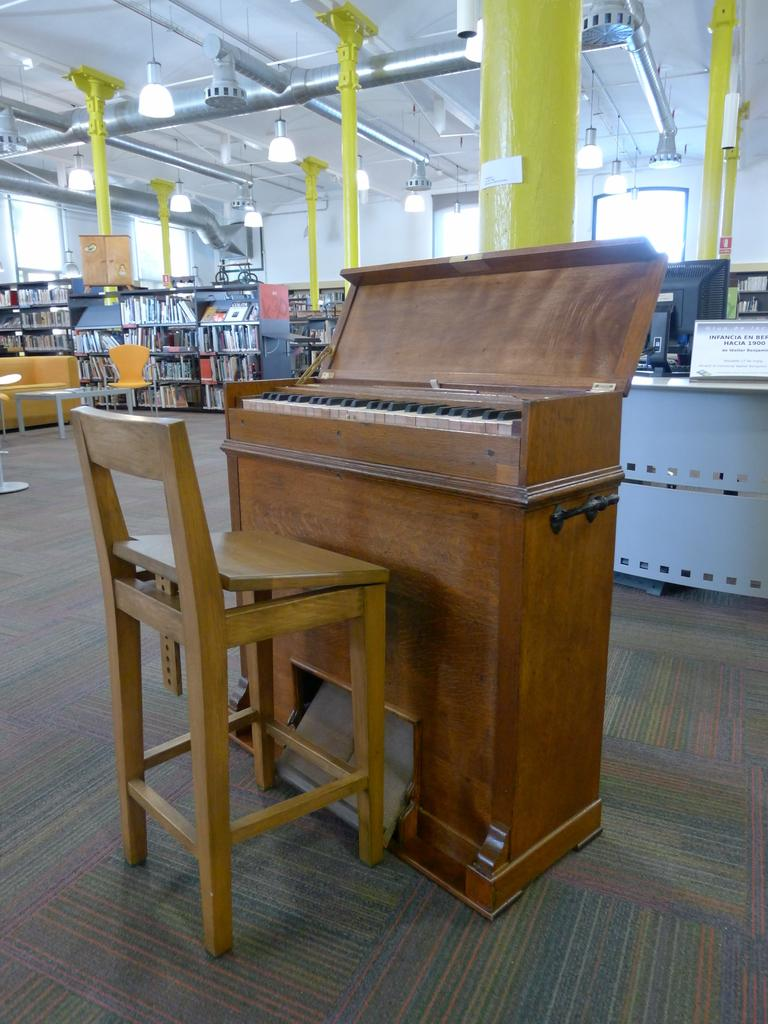What musical instrument is present in the image? There is a piano in the image. What type of furniture is present for seating? There is a chair in the image. What electronic device can be seen on a desk? There is a computer on a desk in the image. Is there any identification or labeling on the desk? Yes, there is a nameplate on the desk. How are books organized in the image? There are many books arranged in a rack. What type of surface is present for placing items? There is a table in the image. What provides illumination in the image? There are lights visible in the image. Is there any plumbing-related object in the image? Yes, there is a pipe in the image. What is the weight of the camp in the image? There is no camp present in the image. How many desks are visible in the image? There is only one desk visible in the image, with a computer and a nameplate on it. 